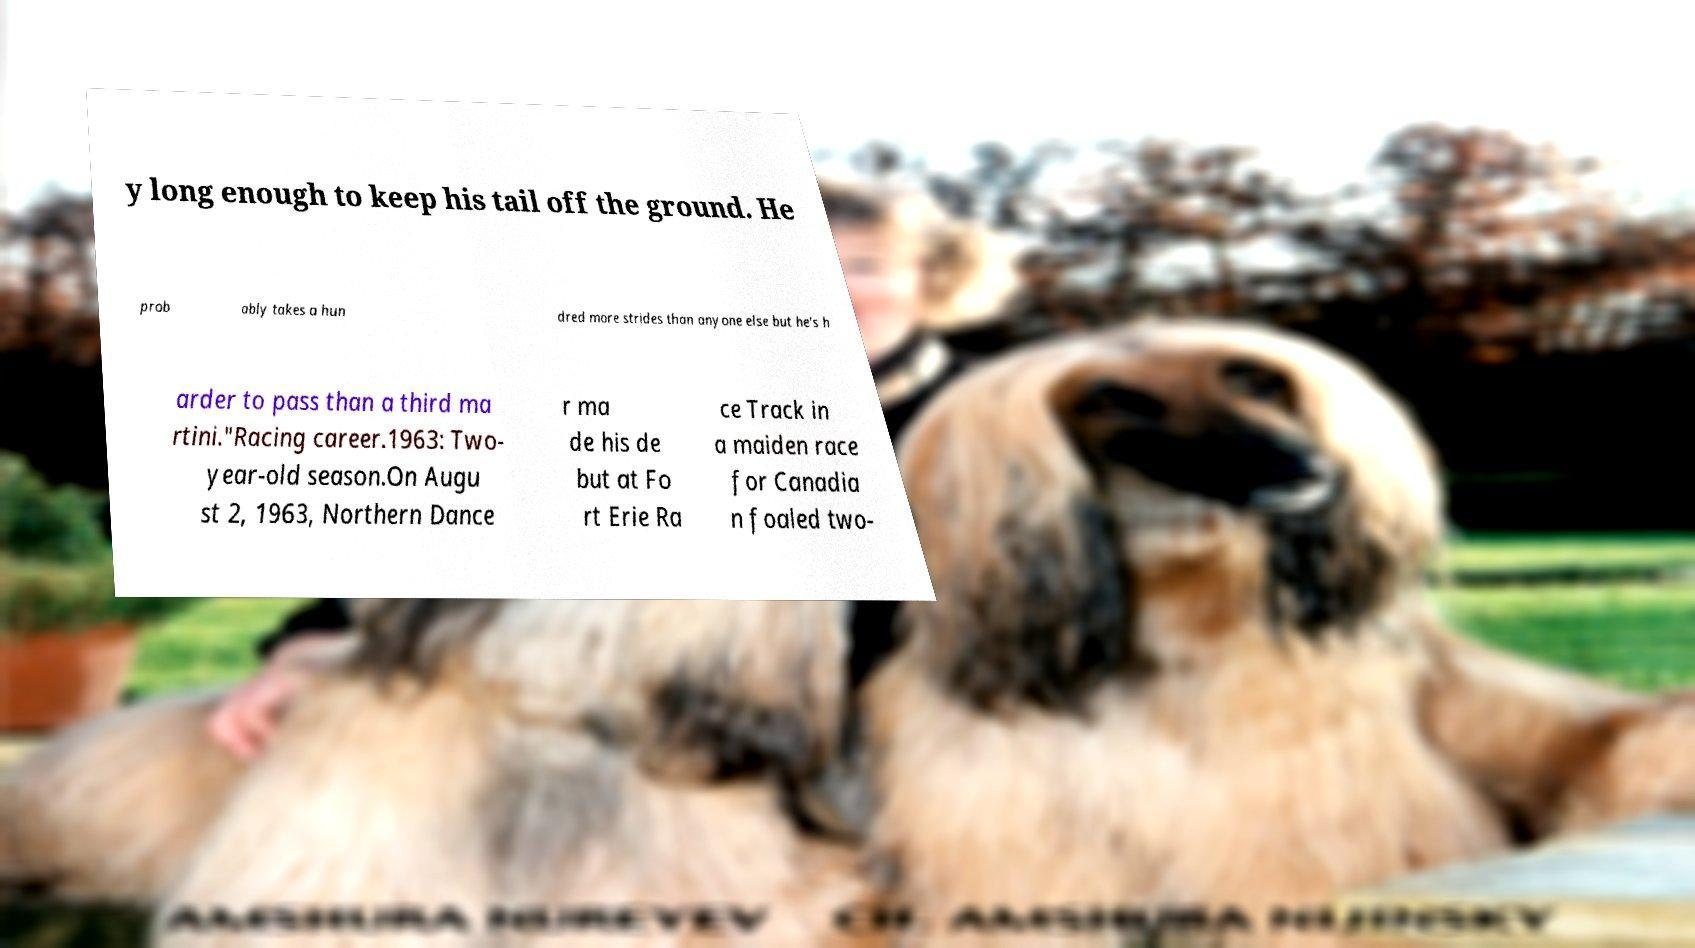For documentation purposes, I need the text within this image transcribed. Could you provide that? y long enough to keep his tail off the ground. He prob ably takes a hun dred more strides than anyone else but he's h arder to pass than a third ma rtini."Racing career.1963: Two- year-old season.On Augu st 2, 1963, Northern Dance r ma de his de but at Fo rt Erie Ra ce Track in a maiden race for Canadia n foaled two- 